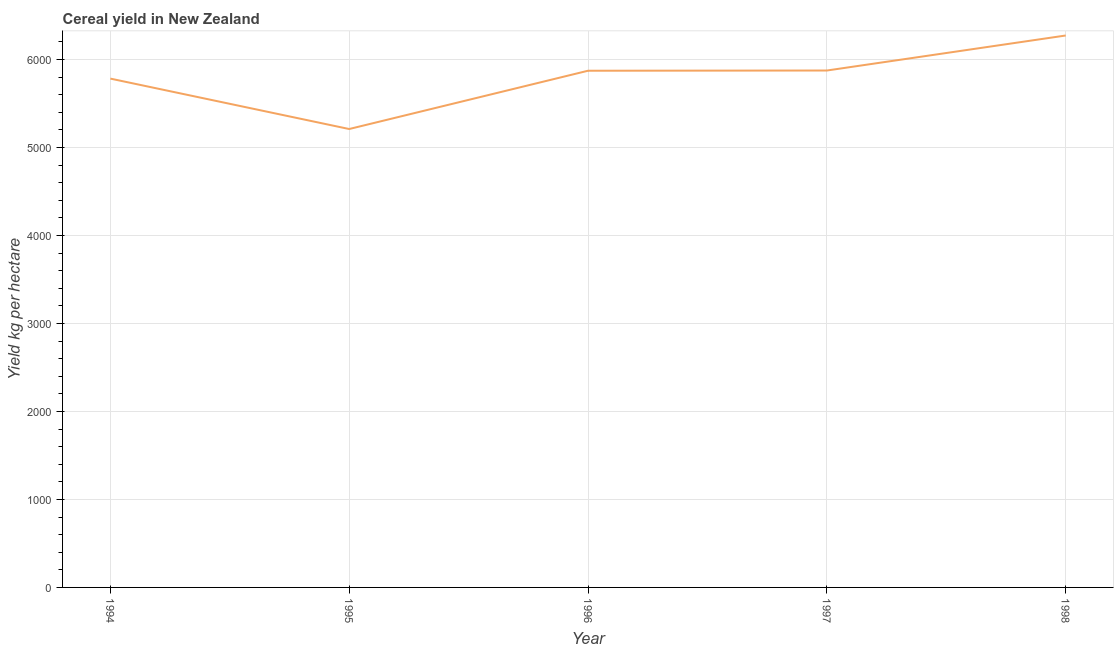What is the cereal yield in 1995?
Your answer should be compact. 5209.43. Across all years, what is the maximum cereal yield?
Make the answer very short. 6272.2. Across all years, what is the minimum cereal yield?
Offer a very short reply. 5209.43. In which year was the cereal yield maximum?
Keep it short and to the point. 1998. What is the sum of the cereal yield?
Ensure brevity in your answer.  2.90e+04. What is the difference between the cereal yield in 1997 and 1998?
Ensure brevity in your answer.  -397.92. What is the average cereal yield per year?
Keep it short and to the point. 5802.03. What is the median cereal yield?
Your answer should be compact. 5871.8. Do a majority of the years between 1996 and 1997 (inclusive) have cereal yield greater than 3200 kg per hectare?
Your answer should be very brief. Yes. What is the ratio of the cereal yield in 1994 to that in 1997?
Make the answer very short. 0.98. What is the difference between the highest and the second highest cereal yield?
Keep it short and to the point. 397.92. Is the sum of the cereal yield in 1995 and 1998 greater than the maximum cereal yield across all years?
Offer a terse response. Yes. What is the difference between the highest and the lowest cereal yield?
Ensure brevity in your answer.  1062.77. Does the cereal yield monotonically increase over the years?
Offer a very short reply. No. What is the difference between two consecutive major ticks on the Y-axis?
Give a very brief answer. 1000. Are the values on the major ticks of Y-axis written in scientific E-notation?
Offer a very short reply. No. Does the graph contain any zero values?
Offer a very short reply. No. Does the graph contain grids?
Give a very brief answer. Yes. What is the title of the graph?
Make the answer very short. Cereal yield in New Zealand. What is the label or title of the X-axis?
Offer a very short reply. Year. What is the label or title of the Y-axis?
Ensure brevity in your answer.  Yield kg per hectare. What is the Yield kg per hectare of 1994?
Offer a terse response. 5782.43. What is the Yield kg per hectare of 1995?
Keep it short and to the point. 5209.43. What is the Yield kg per hectare of 1996?
Make the answer very short. 5871.8. What is the Yield kg per hectare of 1997?
Offer a terse response. 5874.28. What is the Yield kg per hectare of 1998?
Your answer should be very brief. 6272.2. What is the difference between the Yield kg per hectare in 1994 and 1995?
Your answer should be compact. 573. What is the difference between the Yield kg per hectare in 1994 and 1996?
Ensure brevity in your answer.  -89.37. What is the difference between the Yield kg per hectare in 1994 and 1997?
Provide a succinct answer. -91.85. What is the difference between the Yield kg per hectare in 1994 and 1998?
Make the answer very short. -489.77. What is the difference between the Yield kg per hectare in 1995 and 1996?
Your response must be concise. -662.37. What is the difference between the Yield kg per hectare in 1995 and 1997?
Make the answer very short. -664.85. What is the difference between the Yield kg per hectare in 1995 and 1998?
Offer a terse response. -1062.77. What is the difference between the Yield kg per hectare in 1996 and 1997?
Give a very brief answer. -2.48. What is the difference between the Yield kg per hectare in 1996 and 1998?
Your response must be concise. -400.4. What is the difference between the Yield kg per hectare in 1997 and 1998?
Your answer should be compact. -397.92. What is the ratio of the Yield kg per hectare in 1994 to that in 1995?
Ensure brevity in your answer.  1.11. What is the ratio of the Yield kg per hectare in 1994 to that in 1998?
Your response must be concise. 0.92. What is the ratio of the Yield kg per hectare in 1995 to that in 1996?
Offer a terse response. 0.89. What is the ratio of the Yield kg per hectare in 1995 to that in 1997?
Make the answer very short. 0.89. What is the ratio of the Yield kg per hectare in 1995 to that in 1998?
Ensure brevity in your answer.  0.83. What is the ratio of the Yield kg per hectare in 1996 to that in 1998?
Give a very brief answer. 0.94. What is the ratio of the Yield kg per hectare in 1997 to that in 1998?
Ensure brevity in your answer.  0.94. 